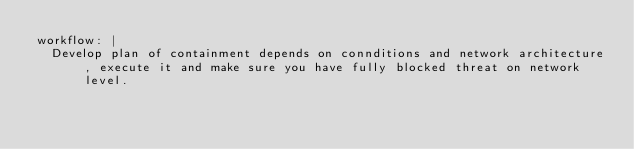Convert code to text. <code><loc_0><loc_0><loc_500><loc_500><_YAML_>workflow: |
  Develop plan of containment depends on connditions and network architecture, execute it and make sure you have fully blocked threat on network level.
</code> 